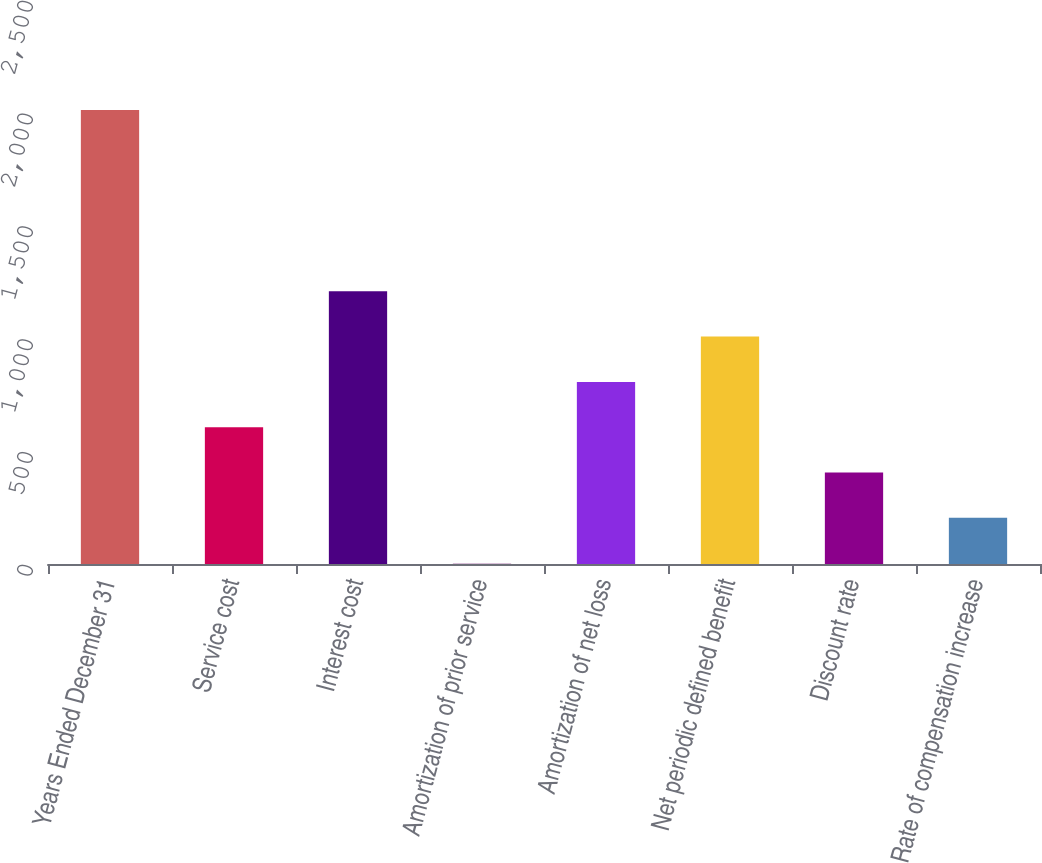Convert chart to OTSL. <chart><loc_0><loc_0><loc_500><loc_500><bar_chart><fcel>Years Ended December 31<fcel>Service cost<fcel>Interest cost<fcel>Amortization of prior service<fcel>Amortization of net loss<fcel>Net periodic defined benefit<fcel>Discount rate<fcel>Rate of compensation increase<nl><fcel>2012<fcel>606.4<fcel>1208.8<fcel>4<fcel>807.2<fcel>1008<fcel>405.6<fcel>204.8<nl></chart> 